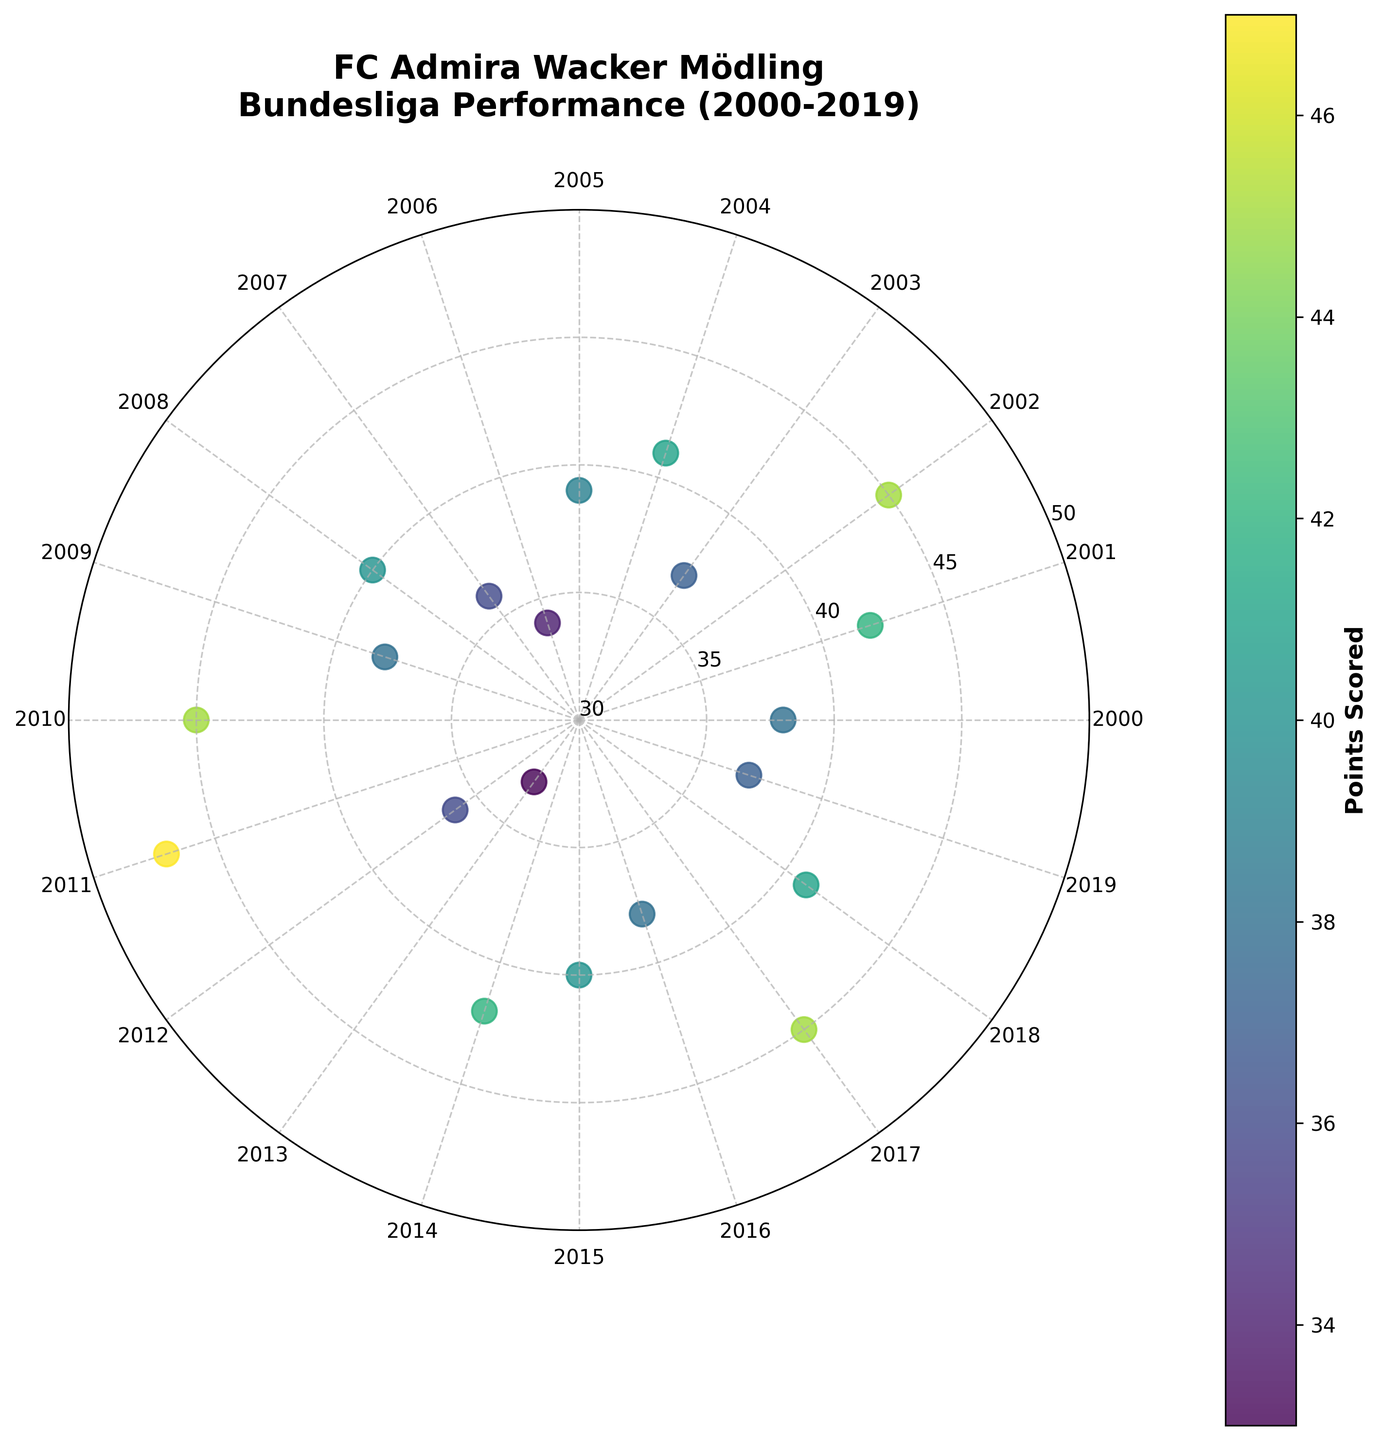What is the title of the plot? The title of the plot is usually found at the top and provides a concise summary of the data displayed. Here, the title is "FC Admira Wacker Mödling\nBundesliga Performance (2000-2019)"
Answer: FC Admira Wacker Mödling\nBundesliga Performance (2000-2019) How many data points are plotted on the chart? The number of data points corresponds to the number of seasons from 2000 to 2019. By counting the years listed, we note there are 20 data points.
Answer: 20 What is the color used for the data points? The data points are color-coded based on the points scored using a color gradient (colorbar). The color ranges from dark to light shades in a 'viridis' color map.
Answer: 'viridis' color gradient What was the maximum number of points scored in a season between 2000 and 2019? Find the highest value on the Points Scored colorbar or locate the highest point on the radial axis. Both show the maximum value as 47 points.
Answer: 47 Which season had the lowest number of points scored? To determine this, we can look for the point closest to the center (30 points) along the radial axis. The lowest point is in 2013, which is 33 points.
Answer: 2013 On average, how many points did FC Admira Wacker Mödling score per season between 2000 and 2019? Sum all the points scored in each season (38+42+45+37+41+39+34+36+40+38+45+47+36+33+42+40+38+45+41+37) which equals 697; divide this sum by the number of seasons (20). The average is 697/20 = 34.85.
Answer: 34.85 What is the range of points scored over the years displayed? The range is the difference between the maximum and minimum points scored. Here, it is 47 (maximum) - 33 (minimum) = 14.
Answer: 14 Which years had points scored greater than 40? Identify the data points which are greater than 40 on the radial axis. These years are 2001, 2002, 2004, 2011, 2014, 2017, and 2018.
Answer: 2001, 2002, 2004, 2011, 2014, 2017, 2018 Between which two consecutive years did the points scored increase the most? By checking year-on-year differences: the largest increase is from 2012 (36 points) to 2013 (47 points), which is an increase of 11 points.
Answer: 2012 to 2013 Between which two consecutive years did the points scored decrease the most? By checking year-on-year differences: the largest decrease is from 2010 (45 points) to 2011 (33 points), which is a decrease of 12 points.
Answer: 2010 to 2011 How does the 'viridis' color gradient help in understanding the data on the plot? The 'viridis' color gradient ranges from dark to light shades and helps in quickly identifying seasons with higher (lighter shades) and lower points (darker shades). It enhances visual differentiation of performance across seasons.
Answer: Color gradient aids in quick visual differentiation 